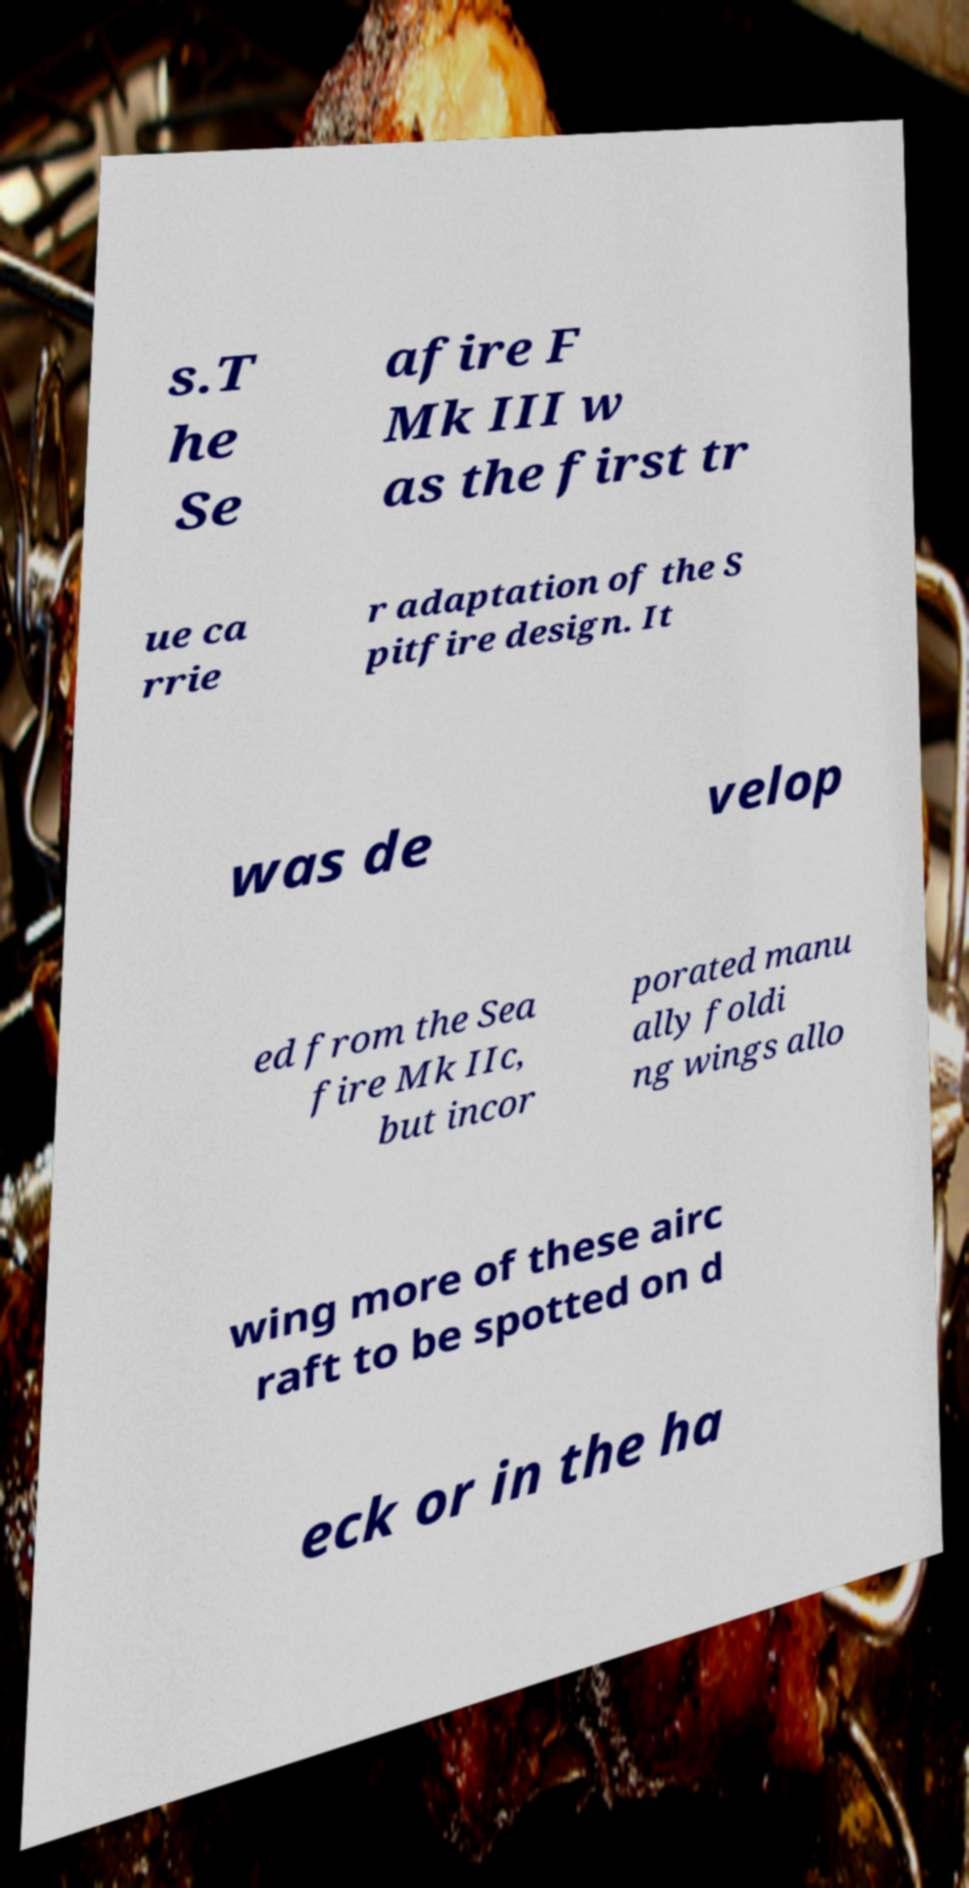I need the written content from this picture converted into text. Can you do that? s.T he Se afire F Mk III w as the first tr ue ca rrie r adaptation of the S pitfire design. It was de velop ed from the Sea fire Mk IIc, but incor porated manu ally foldi ng wings allo wing more of these airc raft to be spotted on d eck or in the ha 